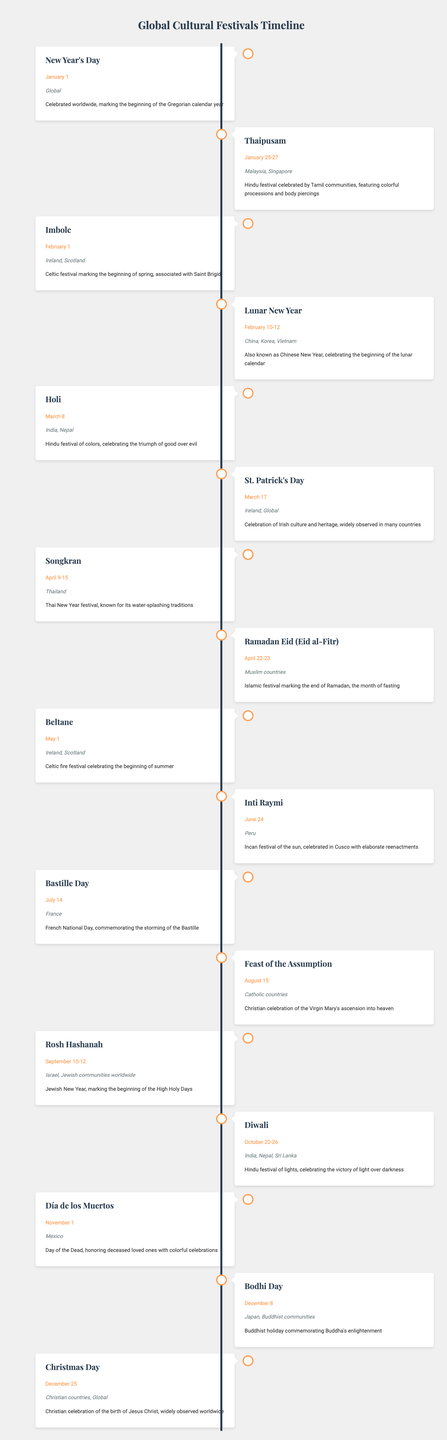What is the event celebrated on January 1? The table lists "New Year's Day" as the event on January 1, which is celebrated globally to mark the beginning of the Gregorian calendar year.
Answer: New Year's Day Which countries celebrate Thaipusam? Thaipusam is celebrated in Malaysia and Singapore, as stated in the table next to the event.
Answer: Malaysia, Singapore How many festivals are celebrated in April? According to the table, there are two festivals listed for April: Songkran from April 9-15 and Ramadan Eid from April 22-23. Therefore, the count of festivals helps us deduce that the total is 2.
Answer: 2 Is Holi celebrated only in India? The table specifies that Holi is celebrated in both India and Nepal, indicating that it is not limited to just India.
Answer: No Which festival occurs in June? The table shows "Inti Raymi" occurring on June 24 in Peru. Hence, this is the festival that takes place in June.
Answer: Inti Raymi What is the total number of festivals listed in the table for the second half of the year (July to December)? The festivals in the second half of the year include Bastille Day (July 14), Feast of the Assumption (August 15), Rosh Hashanah (September 10-12), Diwali (October 22-26), Día de los Muertos (November 1), Bodhi Day (December 8), and Christmas Day (December 25). Counting these gives a total of 7 festivals.
Answer: 7 Does the table include any festivals that are global in nature? The table does mention a few global festivals: New Year's Day and Christmas Day are both celebrated worldwide according to the data. Hence, the answer is yes.
Answer: Yes Which festival is associated with the Virgin Mary? The table points to the Feast of the Assumption on August 15, which is a Christian celebration related to the Virgin Mary's ascension into heaven.
Answer: Feast of the Assumption How does the timing of Diwali compare to Thanksgiving celebrations in the U.S.? Diwali is celebrated between October 22-26, while Thanksgiving in the U.S. usually takes place in late November. Since Diwali occurs earlier in the year, we can conclude its timing is considerably earlier.
Answer: Diwali is earlier than Thanksgiving 